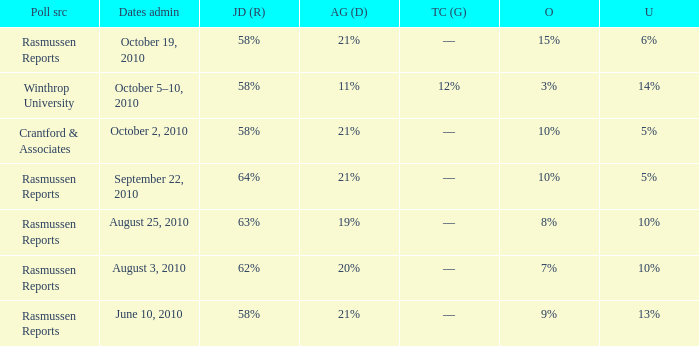Which poll source had an other of 15%? Rasmussen Reports. 